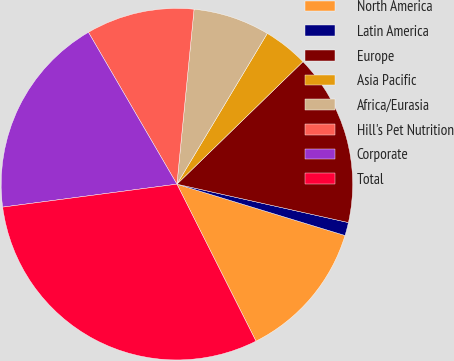Convert chart. <chart><loc_0><loc_0><loc_500><loc_500><pie_chart><fcel>North America<fcel>Latin America<fcel>Europe<fcel>Asia Pacific<fcel>Africa/Eurasia<fcel>Hill's Pet Nutrition<fcel>Corporate<fcel>Total<nl><fcel>12.86%<fcel>1.21%<fcel>15.78%<fcel>4.13%<fcel>7.04%<fcel>9.95%<fcel>18.69%<fcel>30.34%<nl></chart> 